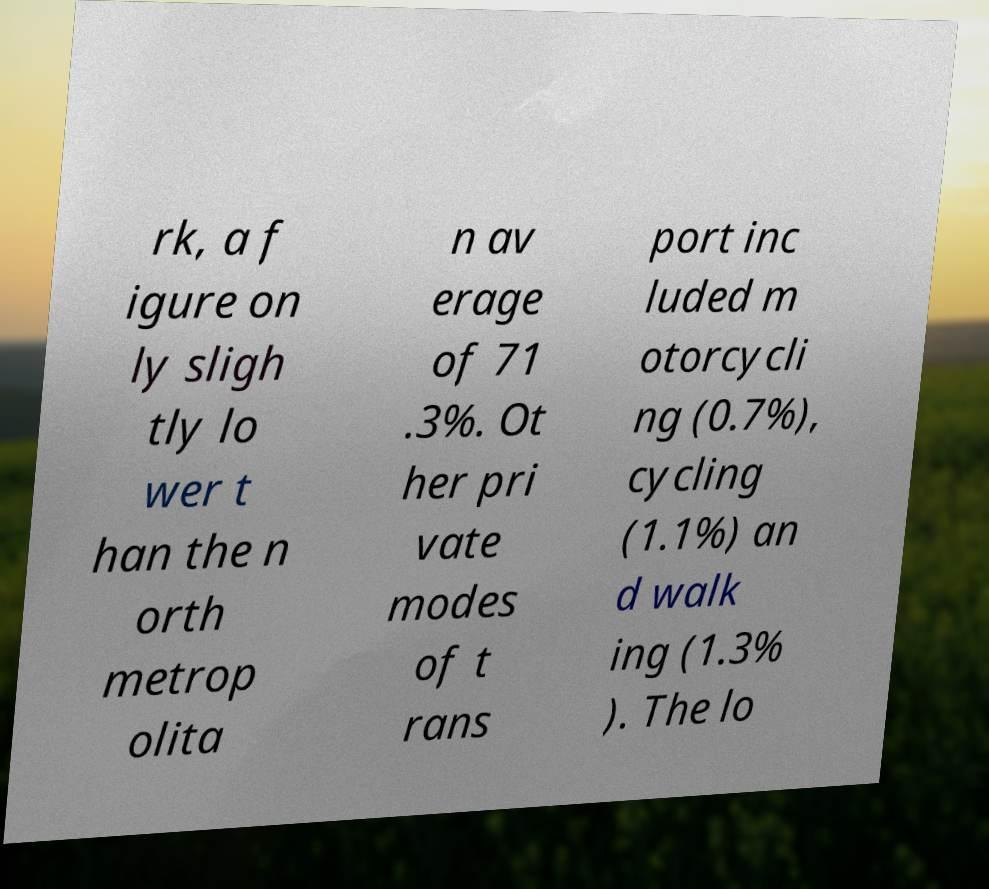There's text embedded in this image that I need extracted. Can you transcribe it verbatim? rk, a f igure on ly sligh tly lo wer t han the n orth metrop olita n av erage of 71 .3%. Ot her pri vate modes of t rans port inc luded m otorcycli ng (0.7%), cycling (1.1%) an d walk ing (1.3% ). The lo 